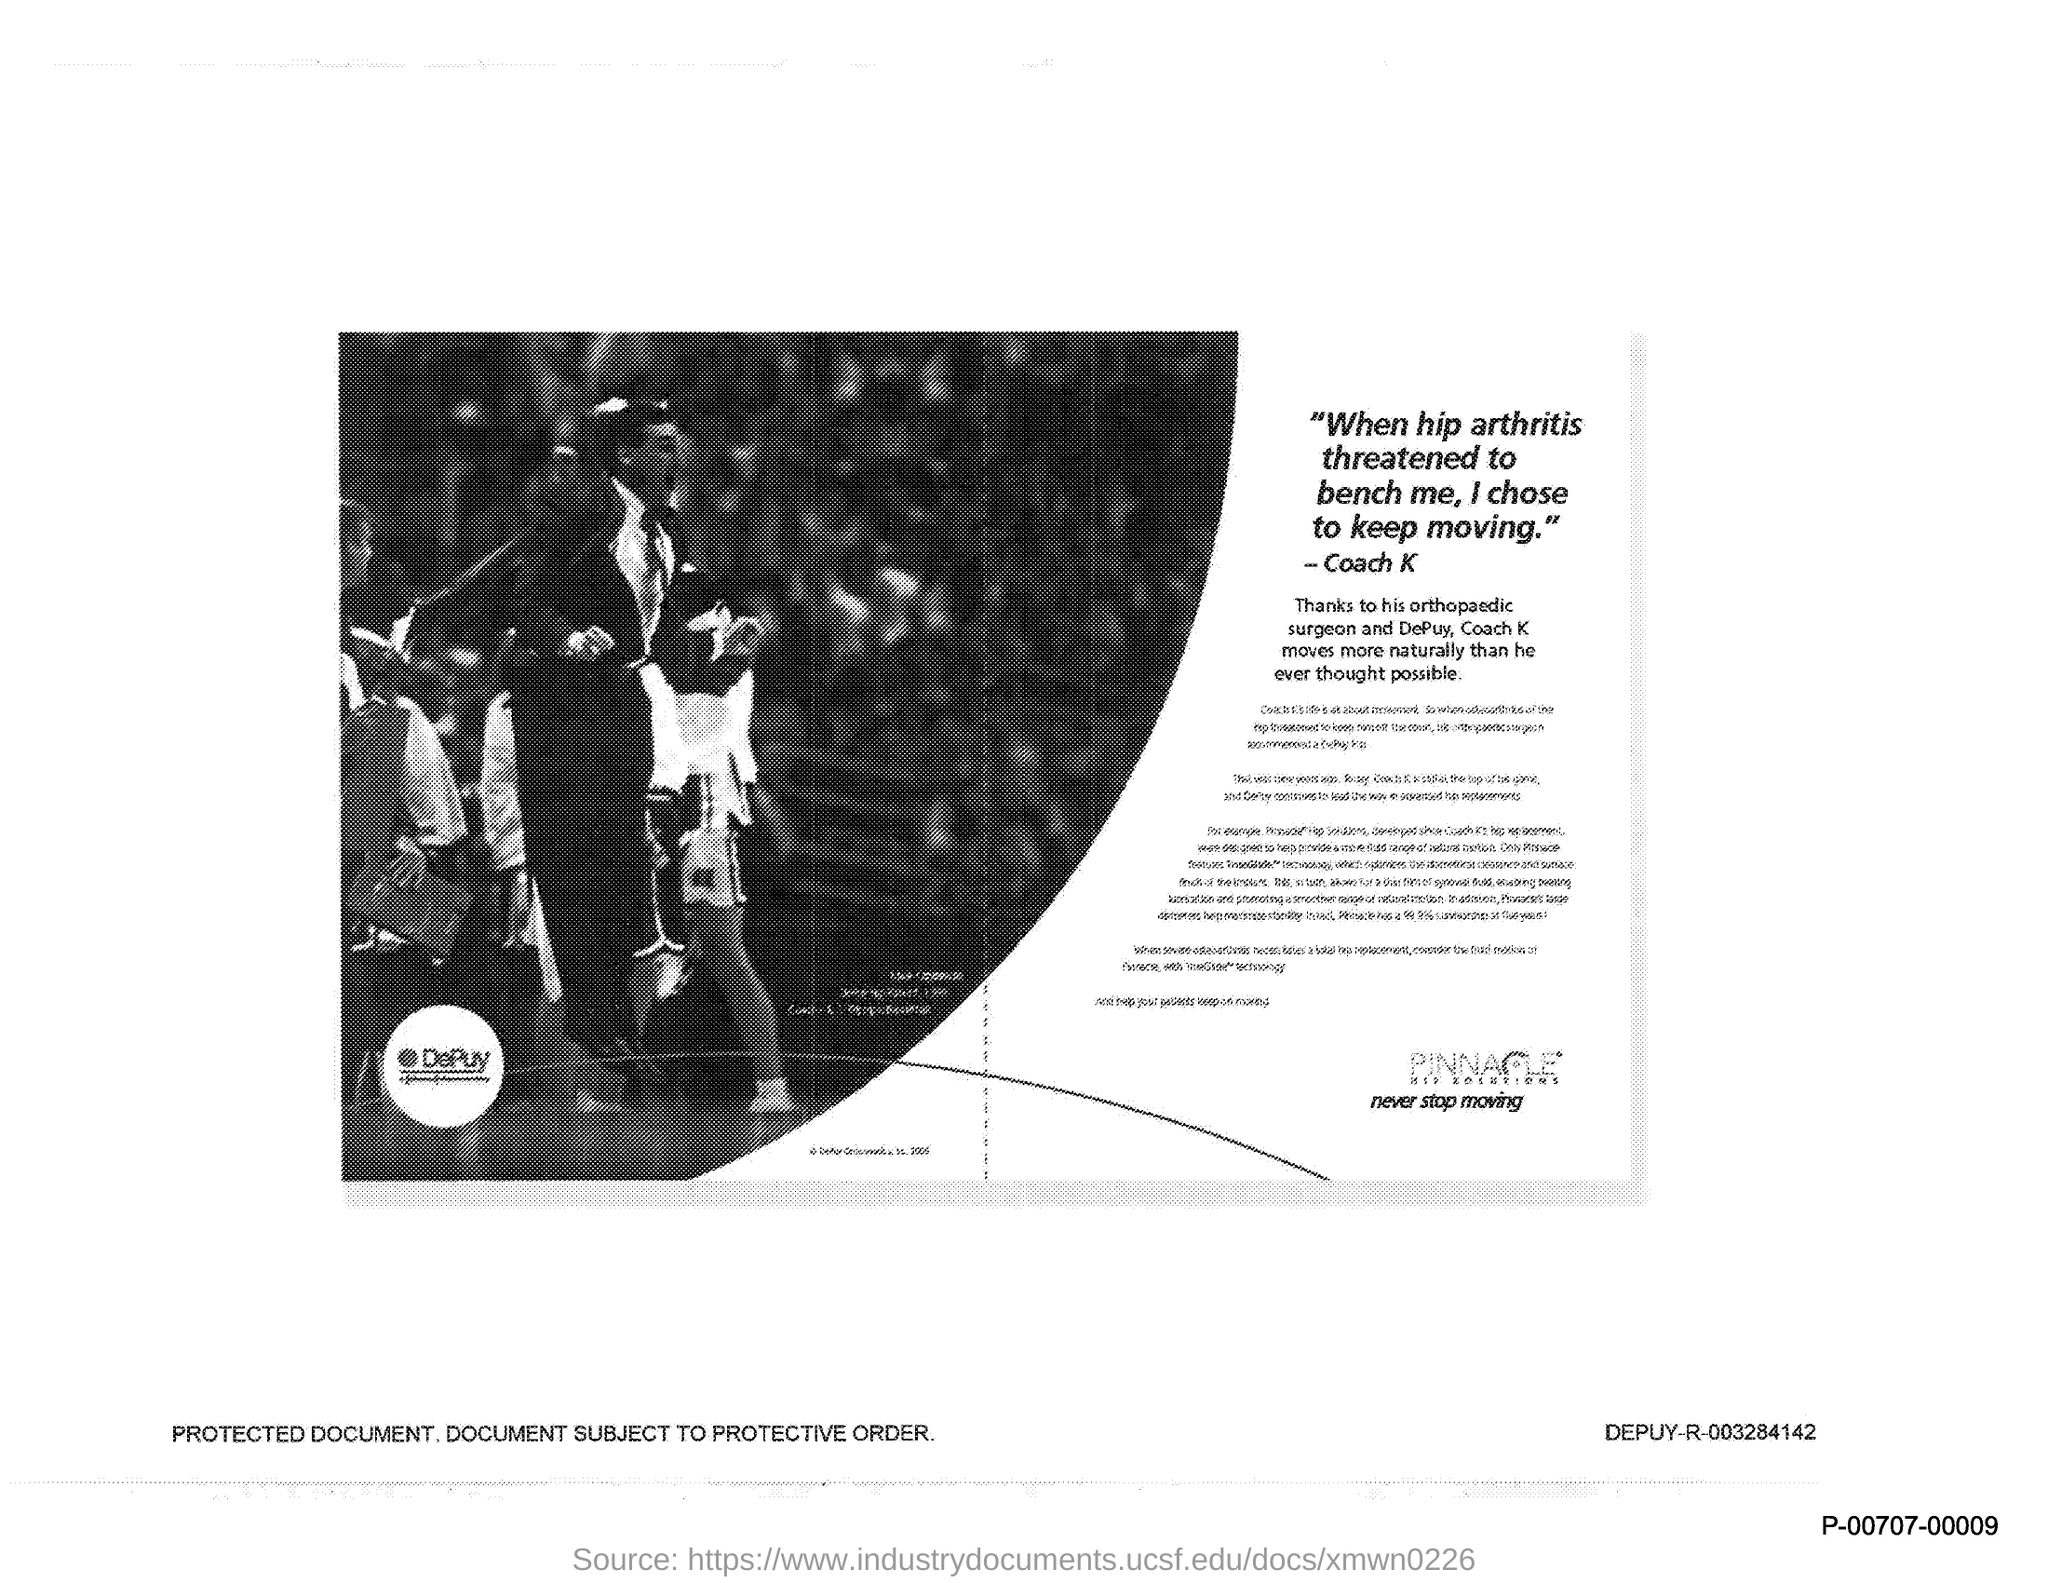Point out several critical features in this image. Coach K was threatened by hip arthritis, a condition that causes joint pain and stiffness. Coach K thanked an orthopedic surgeon and DePuy for their contributions to his success. Who moved more naturally than ever thought possible? Coach K. 